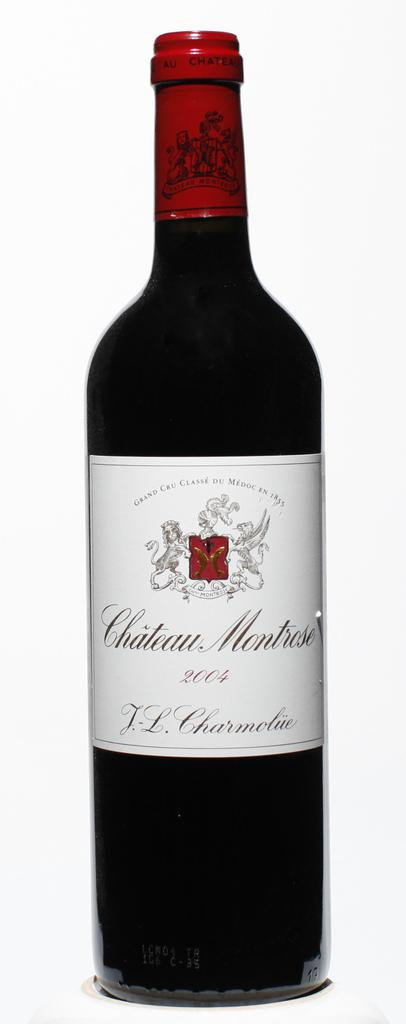Provide a one-sentence caption for the provided image. A bottle of Chateau Montrose wine from 2004. 